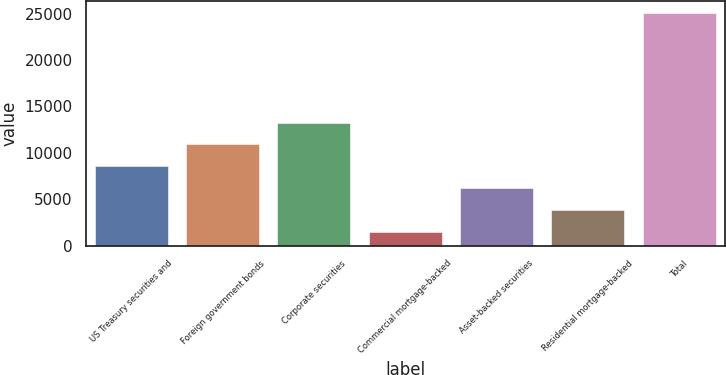<chart> <loc_0><loc_0><loc_500><loc_500><bar_chart><fcel>US Treasury securities and<fcel>Foreign government bonds<fcel>Corporate securities<fcel>Commercial mortgage-backed<fcel>Asset-backed securities<fcel>Residential mortgage-backed<fcel>Total<nl><fcel>8549.5<fcel>10909<fcel>13268.5<fcel>1471<fcel>6190<fcel>3830.5<fcel>25066<nl></chart> 